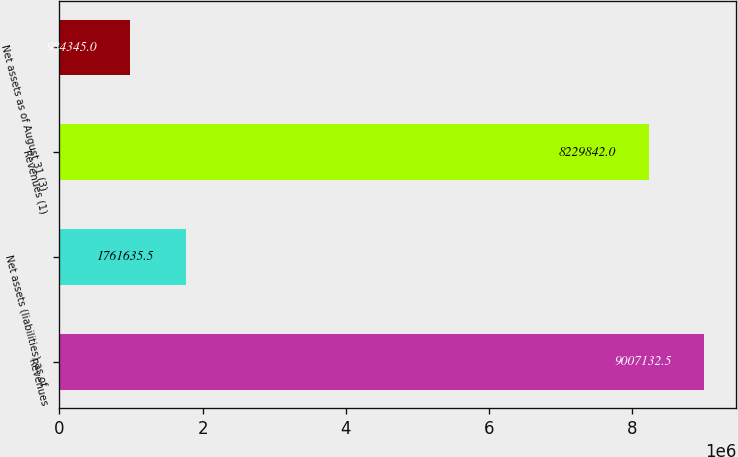Convert chart. <chart><loc_0><loc_0><loc_500><loc_500><bar_chart><fcel>Revenues<fcel>Net assets (liabilities) as of<fcel>Revenues (1)<fcel>Net assets as of August 31 (3)<nl><fcel>9.00713e+06<fcel>1.76164e+06<fcel>8.22984e+06<fcel>984345<nl></chart> 